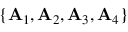<formula> <loc_0><loc_0><loc_500><loc_500>\{ { A } _ { 1 } , { A } _ { 2 } , { A } _ { 3 } , { A } _ { 4 } \}</formula> 